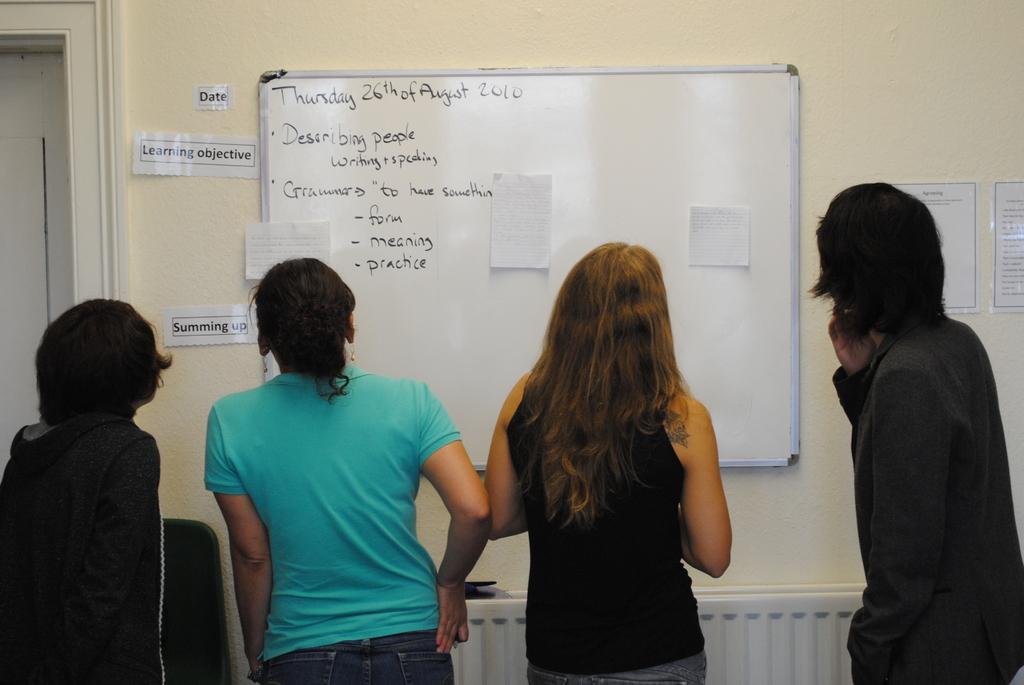What does the white board say?
Offer a terse response. Thursday 26th of august 2010. What year is on the board?
Give a very brief answer. 2010. 